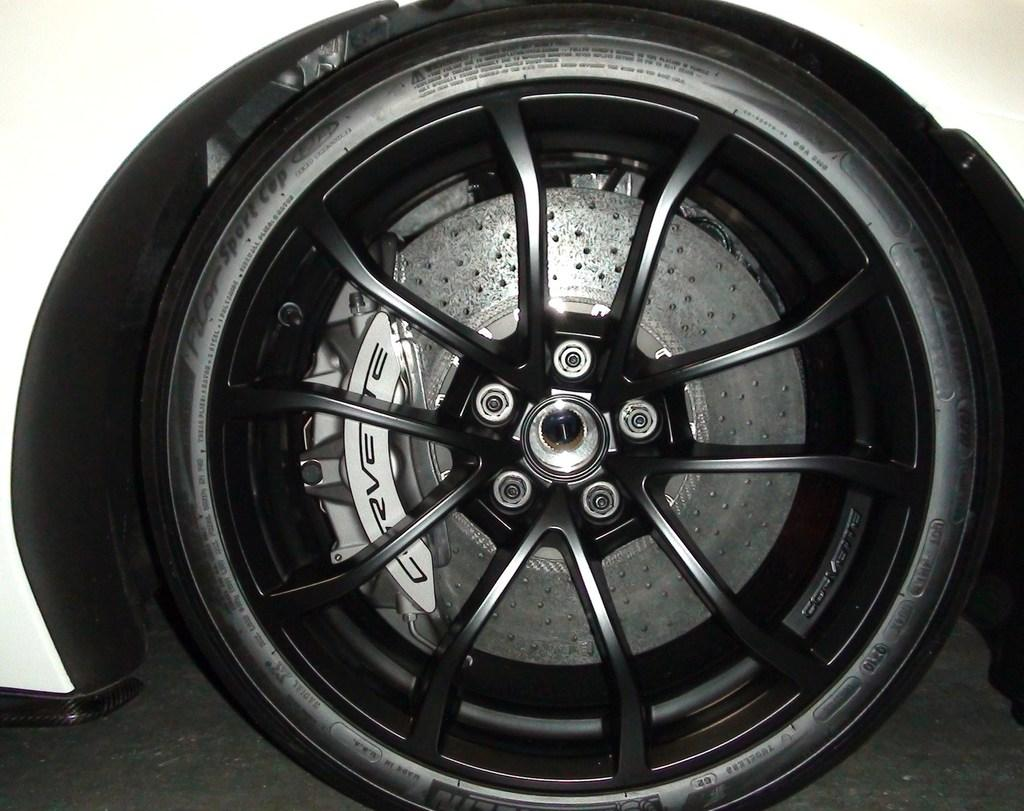What object is featured in the image that has a wheel? The wheel is part of a vehicle in the image. What is the color of the vehicle with the wheel? The vehicle is white in color. What is a specific feature of the wheel in the image? The wheel has spokes. How are the spokes connected to the wheel's center? The spokes are connected to a center cap. What type of vegetable is growing in the territory shown in the image? There is no territory or vegetable present in the image; it features a wheel and a vehicle. 